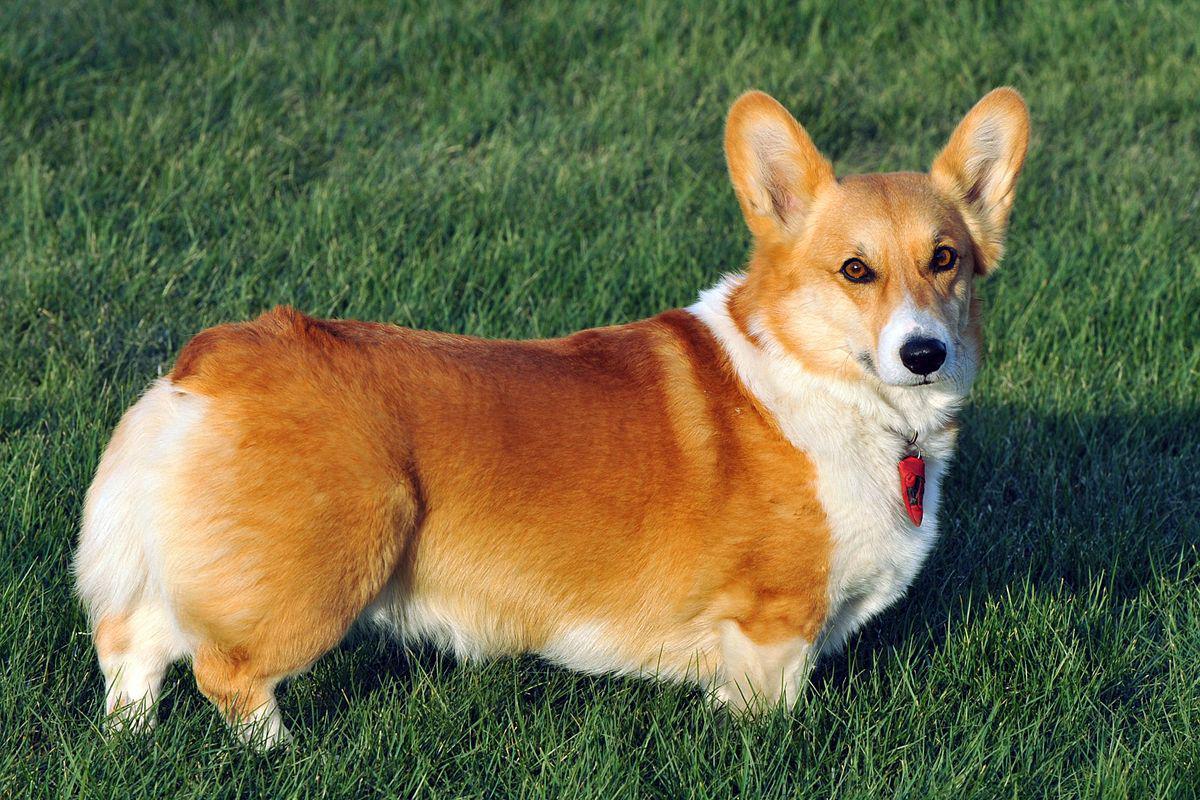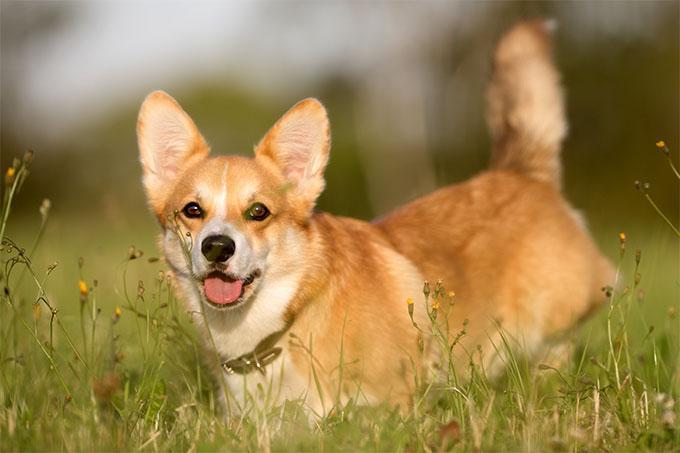The first image is the image on the left, the second image is the image on the right. For the images shown, is this caption "Each image shows exactly one short-legged dog standing in the grass." true? Answer yes or no. Yes. The first image is the image on the left, the second image is the image on the right. Assess this claim about the two images: "The bodies of the dogs in the two images turn toward each other.". Correct or not? Answer yes or no. Yes. The first image is the image on the left, the second image is the image on the right. For the images shown, is this caption "There are at least three dogs in a grassy area." true? Answer yes or no. No. The first image is the image on the left, the second image is the image on the right. For the images shown, is this caption "Both images show short-legged dogs standing on grass." true? Answer yes or no. Yes. 